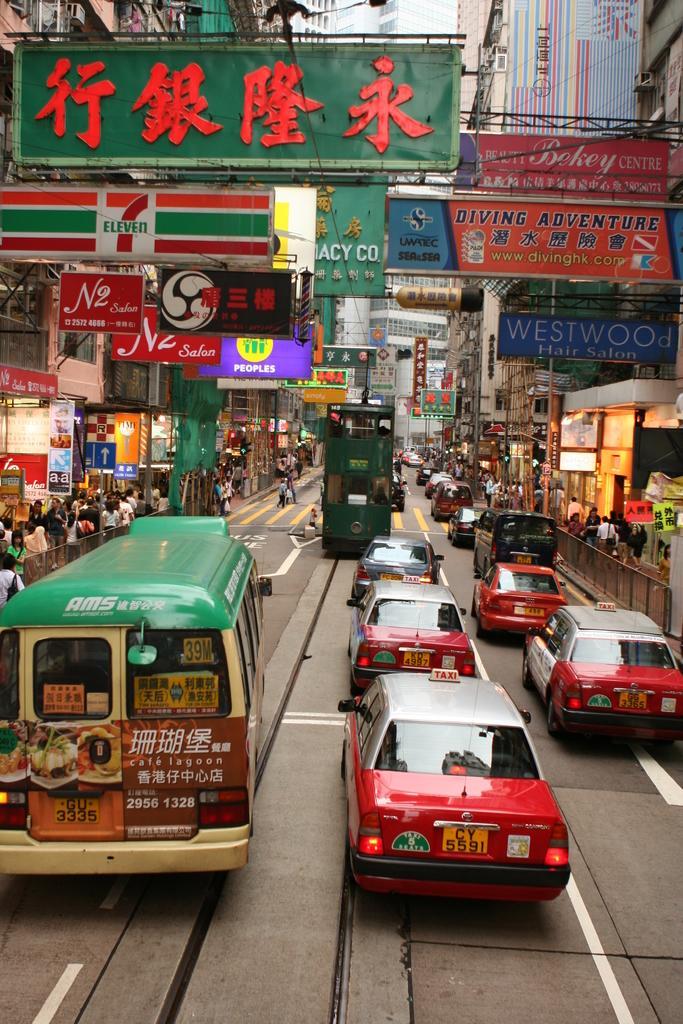How would you summarize this image in a sentence or two? Here there are vehicles on the road. To either side of the road we can see fences,few persons,stores,buildings and hoardings. In the background there are buildings,hoardings boards,poles,windows,wires and other objects. 